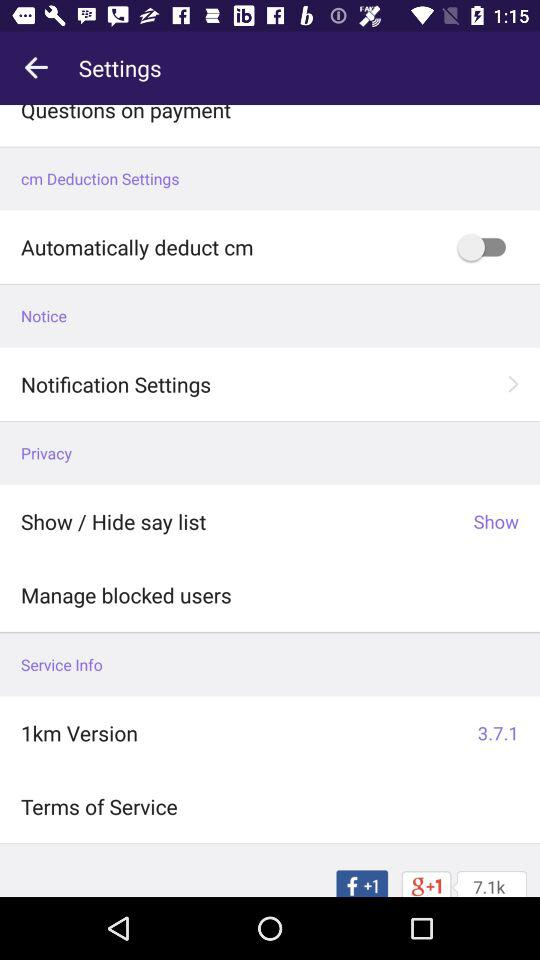Is "Automatically deduct cm" on or off? "Automatically deduct cm" is "off". 